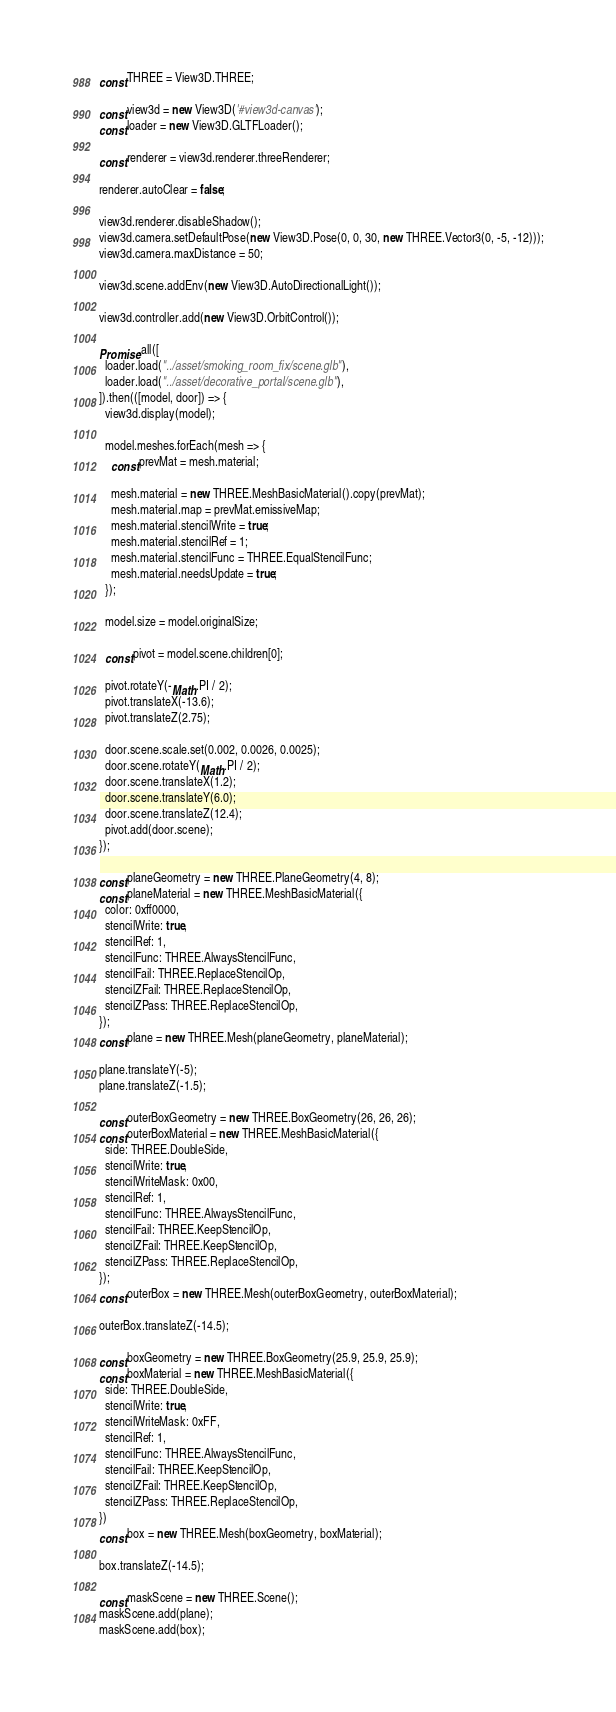Convert code to text. <code><loc_0><loc_0><loc_500><loc_500><_JavaScript_>const THREE = View3D.THREE;

const view3d = new View3D('#view3d-canvas');
const loader = new View3D.GLTFLoader();

const renderer = view3d.renderer.threeRenderer;

renderer.autoClear = false;

view3d.renderer.disableShadow();
view3d.camera.setDefaultPose(new View3D.Pose(0, 0, 30, new THREE.Vector3(0, -5, -12)));
view3d.camera.maxDistance = 50;

view3d.scene.addEnv(new View3D.AutoDirectionalLight());

view3d.controller.add(new View3D.OrbitControl());

Promise.all([
  loader.load("../asset/smoking_room_fix/scene.glb"),
  loader.load("../asset/decorative_portal/scene.glb"),
]).then(([model, door]) => {
  view3d.display(model);

  model.meshes.forEach(mesh => {
    const prevMat = mesh.material;

    mesh.material = new THREE.MeshBasicMaterial().copy(prevMat);
    mesh.material.map = prevMat.emissiveMap;
    mesh.material.stencilWrite = true;
    mesh.material.stencilRef = 1;
    mesh.material.stencilFunc = THREE.EqualStencilFunc;
    mesh.material.needsUpdate = true;
  });

  model.size = model.originalSize;

  const pivot = model.scene.children[0];

  pivot.rotateY(-Math.PI / 2);
  pivot.translateX(-13.6);
  pivot.translateZ(2.75);

  door.scene.scale.set(0.002, 0.0026, 0.0025);
  door.scene.rotateY(Math.PI / 2);
  door.scene.translateX(1.2);
  door.scene.translateY(6.0);
  door.scene.translateZ(12.4);
  pivot.add(door.scene);
});

const planeGeometry = new THREE.PlaneGeometry(4, 8);
const planeMaterial = new THREE.MeshBasicMaterial({
  color: 0xff0000,
  stencilWrite: true,
  stencilRef: 1,
  stencilFunc: THREE.AlwaysStencilFunc,
  stencilFail: THREE.ReplaceStencilOp,
  stencilZFail: THREE.ReplaceStencilOp,
  stencilZPass: THREE.ReplaceStencilOp,
});
const plane = new THREE.Mesh(planeGeometry, planeMaterial);

plane.translateY(-5);
plane.translateZ(-1.5);

const outerBoxGeometry = new THREE.BoxGeometry(26, 26, 26);
const outerBoxMaterial = new THREE.MeshBasicMaterial({
  side: THREE.DoubleSide,
  stencilWrite: true,
  stencilWriteMask: 0x00,
  stencilRef: 1,
  stencilFunc: THREE.AlwaysStencilFunc,
  stencilFail: THREE.KeepStencilOp,
  stencilZFail: THREE.KeepStencilOp,
  stencilZPass: THREE.ReplaceStencilOp,
});
const outerBox = new THREE.Mesh(outerBoxGeometry, outerBoxMaterial);

outerBox.translateZ(-14.5);

const boxGeometry = new THREE.BoxGeometry(25.9, 25.9, 25.9);
const boxMaterial = new THREE.MeshBasicMaterial({
  side: THREE.DoubleSide,
  stencilWrite: true,
  stencilWriteMask: 0xFF,
  stencilRef: 1,
  stencilFunc: THREE.AlwaysStencilFunc,
  stencilFail: THREE.KeepStencilOp,
  stencilZFail: THREE.KeepStencilOp,
  stencilZPass: THREE.ReplaceStencilOp,
})
const box = new THREE.Mesh(boxGeometry, boxMaterial);

box.translateZ(-14.5);

const maskScene = new THREE.Scene();
maskScene.add(plane);
maskScene.add(box);</code> 